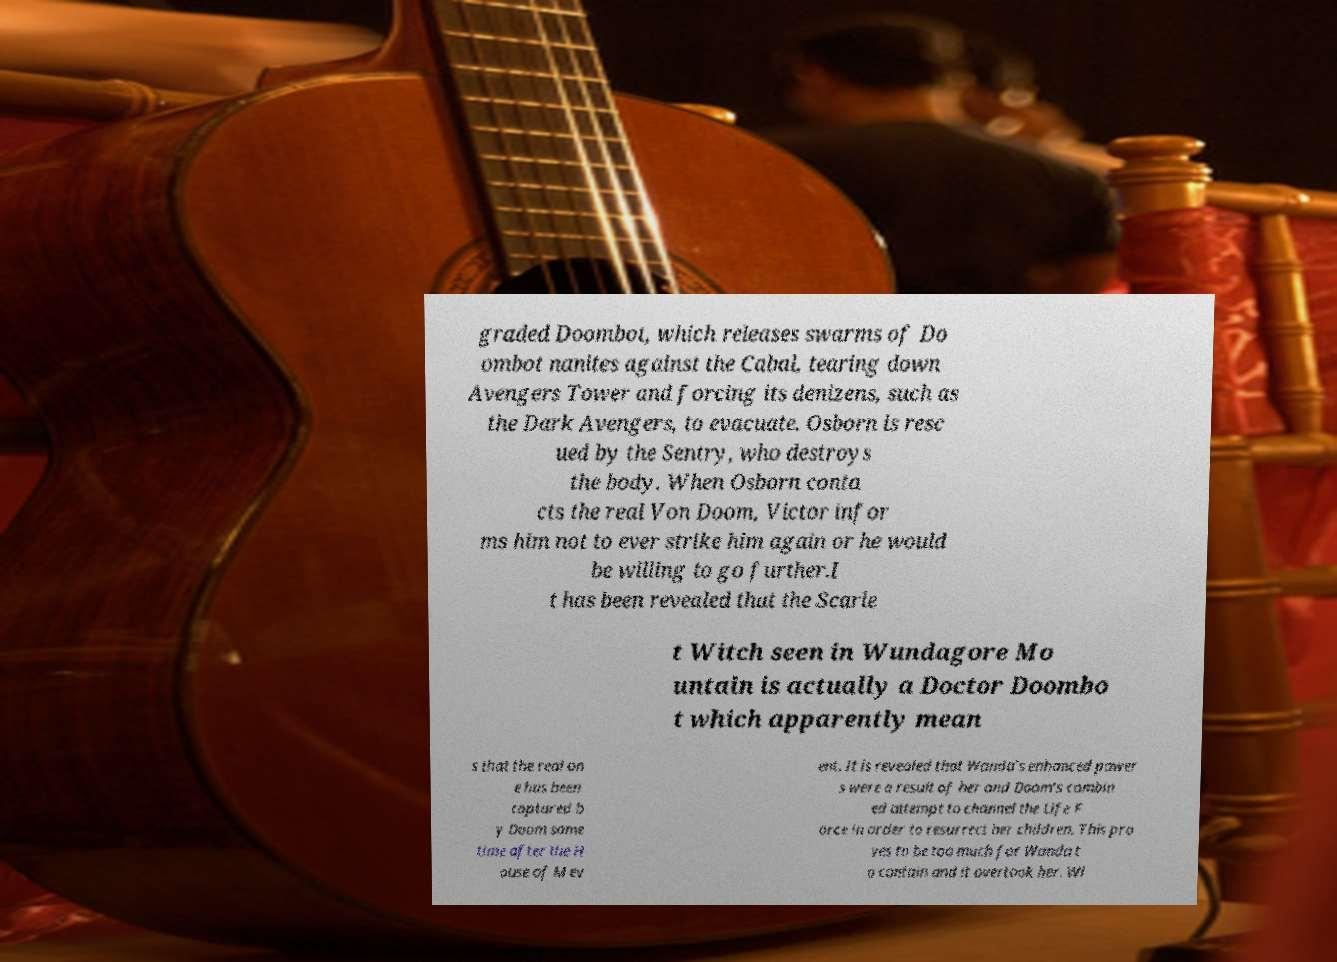What messages or text are displayed in this image? I need them in a readable, typed format. graded Doombot, which releases swarms of Do ombot nanites against the Cabal, tearing down Avengers Tower and forcing its denizens, such as the Dark Avengers, to evacuate. Osborn is resc ued by the Sentry, who destroys the body. When Osborn conta cts the real Von Doom, Victor infor ms him not to ever strike him again or he would be willing to go further.I t has been revealed that the Scarle t Witch seen in Wundagore Mo untain is actually a Doctor Doombo t which apparently mean s that the real on e has been captured b y Doom some time after the H ouse of M ev ent. It is revealed that Wanda's enhanced power s were a result of her and Doom's combin ed attempt to channel the Life F orce in order to resurrect her children. This pro ves to be too much for Wanda t o contain and it overtook her. Wi 